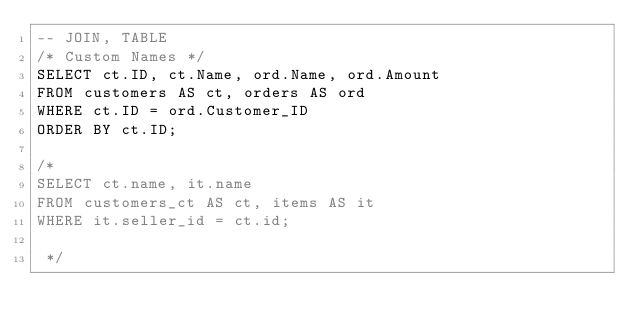Convert code to text. <code><loc_0><loc_0><loc_500><loc_500><_SQL_>-- JOIN, TABLE
/* Custom Names */
SELECT ct.ID, ct.Name, ord.Name, ord.Amount
FROM customers AS ct, orders AS ord
WHERE ct.ID = ord.Customer_ID
ORDER BY ct.ID;

/*
SELECT ct.name, it.name
FROM customers_ct AS ct, items AS it
WHERE it.seller_id = ct.id;

 */
</code> 